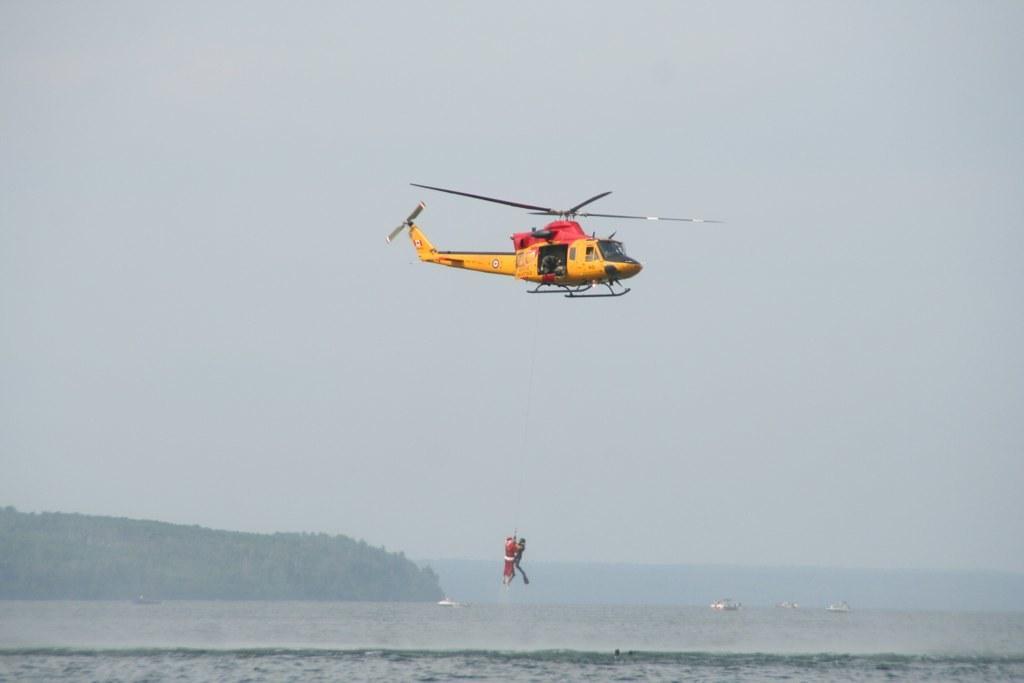Could you give a brief overview of what you see in this image? In the middle of the image there is a helicopter and few people are hanging from helicopter. Behind the helicopter there are some clouds and sky. Bottom of the image there is water, on the water there are some ships. Top left side of the image there are some hills. 